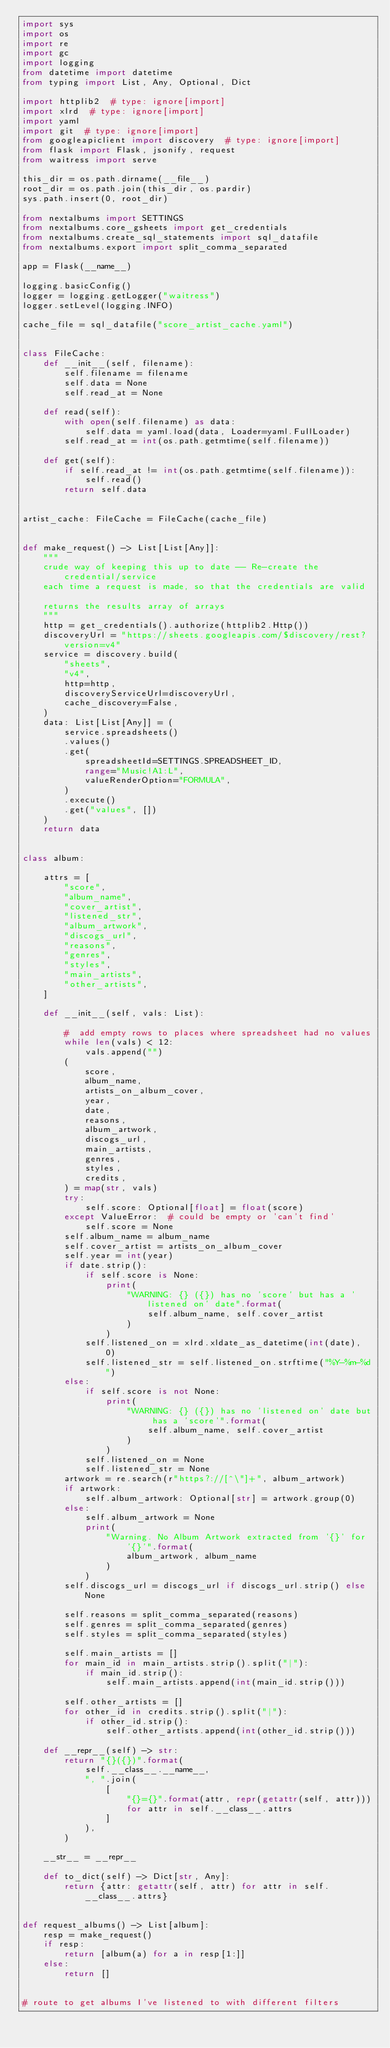<code> <loc_0><loc_0><loc_500><loc_500><_Python_>import sys
import os
import re
import gc
import logging
from datetime import datetime
from typing import List, Any, Optional, Dict

import httplib2  # type: ignore[import]
import xlrd  # type: ignore[import]
import yaml
import git  # type: ignore[import]
from googleapiclient import discovery  # type: ignore[import]
from flask import Flask, jsonify, request
from waitress import serve

this_dir = os.path.dirname(__file__)
root_dir = os.path.join(this_dir, os.pardir)
sys.path.insert(0, root_dir)

from nextalbums import SETTINGS
from nextalbums.core_gsheets import get_credentials
from nextalbums.create_sql_statements import sql_datafile
from nextalbums.export import split_comma_separated

app = Flask(__name__)

logging.basicConfig()
logger = logging.getLogger("waitress")
logger.setLevel(logging.INFO)

cache_file = sql_datafile("score_artist_cache.yaml")


class FileCache:
    def __init__(self, filename):
        self.filename = filename
        self.data = None
        self.read_at = None

    def read(self):
        with open(self.filename) as data:
            self.data = yaml.load(data, Loader=yaml.FullLoader)
        self.read_at = int(os.path.getmtime(self.filename))

    def get(self):
        if self.read_at != int(os.path.getmtime(self.filename)):
            self.read()
        return self.data


artist_cache: FileCache = FileCache(cache_file)


def make_request() -> List[List[Any]]:
    """
    crude way of keeping this up to date -- Re-create the credential/service
    each time a request is made, so that the credentials are valid

    returns the results array of arrays
    """
    http = get_credentials().authorize(httplib2.Http())
    discoveryUrl = "https://sheets.googleapis.com/$discovery/rest?version=v4"
    service = discovery.build(
        "sheets",
        "v4",
        http=http,
        discoveryServiceUrl=discoveryUrl,
        cache_discovery=False,
    )
    data: List[List[Any]] = (
        service.spreadsheets()
        .values()
        .get(
            spreadsheetId=SETTINGS.SPREADSHEET_ID,
            range="Music!A1:L",
            valueRenderOption="FORMULA",
        )
        .execute()
        .get("values", [])
    )
    return data


class album:

    attrs = [
        "score",
        "album_name",
        "cover_artist",
        "listened_str",
        "album_artwork",
        "discogs_url",
        "reasons",
        "genres",
        "styles",
        "main_artists",
        "other_artists",
    ]

    def __init__(self, vals: List):

        #  add empty rows to places where spreadsheet had no values
        while len(vals) < 12:
            vals.append("")
        (
            score,
            album_name,
            artists_on_album_cover,
            year,
            date,
            reasons,
            album_artwork,
            discogs_url,
            main_artists,
            genres,
            styles,
            credits,
        ) = map(str, vals)
        try:
            self.score: Optional[float] = float(score)
        except ValueError:  # could be empty or 'can't find'
            self.score = None
        self.album_name = album_name
        self.cover_artist = artists_on_album_cover
        self.year = int(year)
        if date.strip():
            if self.score is None:
                print(
                    "WARNING: {} ({}) has no 'score' but has a 'listened on' date".format(
                        self.album_name, self.cover_artist
                    )
                )
            self.listened_on = xlrd.xldate_as_datetime(int(date), 0)
            self.listened_str = self.listened_on.strftime("%Y-%m-%d")
        else:
            if self.score is not None:
                print(
                    "WARNING: {} ({}) has no 'listened on' date but has a 'score'".format(
                        self.album_name, self.cover_artist
                    )
                )
            self.listened_on = None
            self.listened_str = None
        artwork = re.search(r"https?://[^\"]+", album_artwork)
        if artwork:
            self.album_artwork: Optional[str] = artwork.group(0)
        else:
            self.album_artwork = None
            print(
                "Warning. No Album Artwork extracted from '{}' for '{}'".format(
                    album_artwork, album_name
                )
            )
        self.discogs_url = discogs_url if discogs_url.strip() else None

        self.reasons = split_comma_separated(reasons)
        self.genres = split_comma_separated(genres)
        self.styles = split_comma_separated(styles)

        self.main_artists = []
        for main_id in main_artists.strip().split("|"):
            if main_id.strip():
                self.main_artists.append(int(main_id.strip()))

        self.other_artists = []
        for other_id in credits.strip().split("|"):
            if other_id.strip():
                self.other_artists.append(int(other_id.strip()))

    def __repr__(self) -> str:
        return "{}({})".format(
            self.__class__.__name__,
            ", ".join(
                [
                    "{}={}".format(attr, repr(getattr(self, attr)))
                    for attr in self.__class__.attrs
                ]
            ),
        )

    __str__ = __repr__

    def to_dict(self) -> Dict[str, Any]:
        return {attr: getattr(self, attr) for attr in self.__class__.attrs}


def request_albums() -> List[album]:
    resp = make_request()
    if resp:
        return [album(a) for a in resp[1:]]
    else:
        return []


# route to get albums I've listened to with different filters</code> 